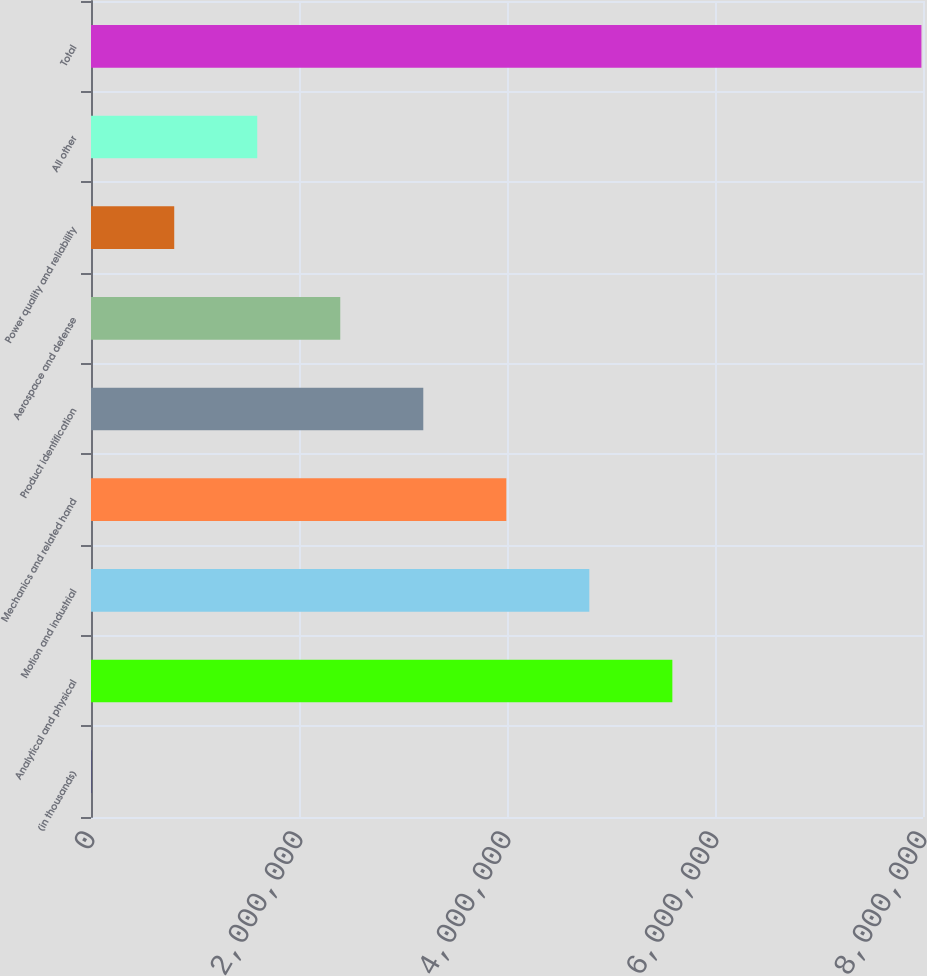Convert chart. <chart><loc_0><loc_0><loc_500><loc_500><bar_chart><fcel>(in thousands)<fcel>Analytical and physical<fcel>Motion and industrial<fcel>Mechanics and related hand<fcel>Product identification<fcel>Aerospace and defense<fcel>Power quality and reliability<fcel>All other<fcel>Total<nl><fcel>2005<fcel>5.58989e+06<fcel>4.79162e+06<fcel>3.99335e+06<fcel>3.19508e+06<fcel>2.39681e+06<fcel>800275<fcel>1.59854e+06<fcel>7.9847e+06<nl></chart> 